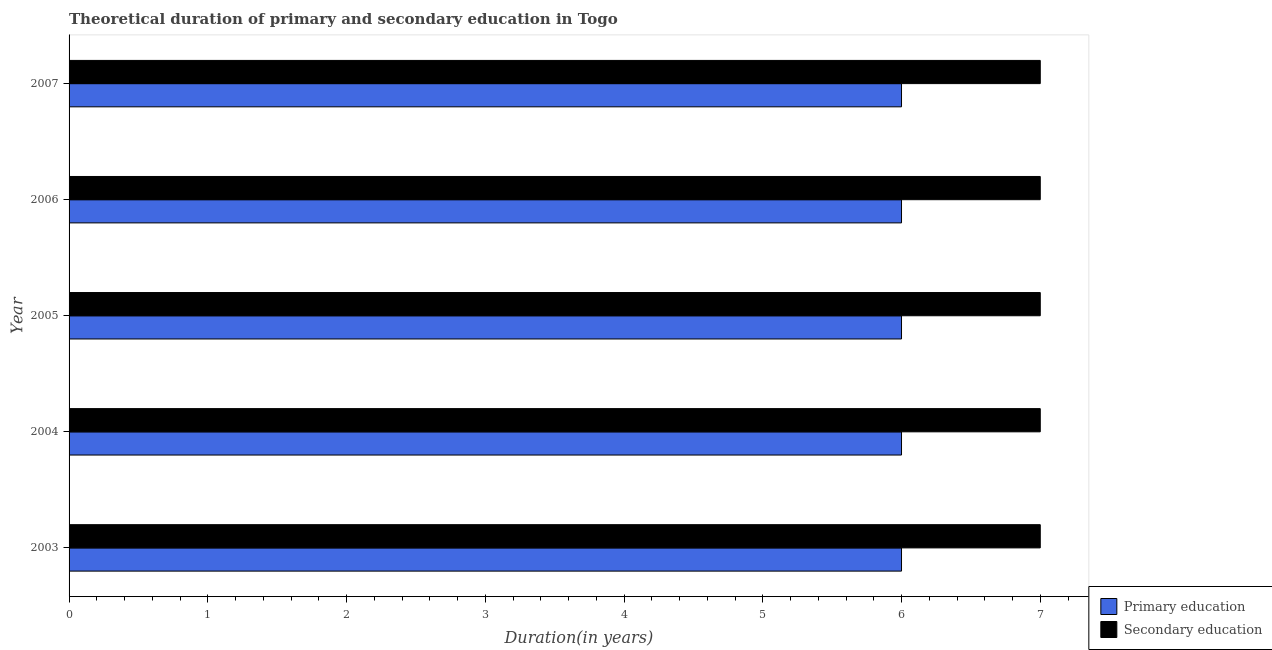Are the number of bars on each tick of the Y-axis equal?
Provide a succinct answer. Yes. What is the label of the 2nd group of bars from the top?
Your response must be concise. 2006. In how many cases, is the number of bars for a given year not equal to the number of legend labels?
Keep it short and to the point. 0. Across all years, what is the maximum duration of secondary education?
Make the answer very short. 7. Across all years, what is the minimum duration of secondary education?
Your response must be concise. 7. In which year was the duration of primary education maximum?
Your answer should be very brief. 2003. In which year was the duration of primary education minimum?
Your response must be concise. 2003. What is the total duration of secondary education in the graph?
Ensure brevity in your answer.  35. What is the difference between the duration of primary education in 2003 and that in 2005?
Your answer should be very brief. 0. What is the difference between the duration of primary education in 2003 and the duration of secondary education in 2004?
Give a very brief answer. -1. What is the average duration of secondary education per year?
Your answer should be compact. 7. In the year 2007, what is the difference between the duration of secondary education and duration of primary education?
Make the answer very short. 1. What is the ratio of the duration of primary education in 2003 to that in 2005?
Offer a terse response. 1. What does the 1st bar from the top in 2004 represents?
Keep it short and to the point. Secondary education. What does the 2nd bar from the bottom in 2004 represents?
Provide a succinct answer. Secondary education. How many years are there in the graph?
Provide a short and direct response. 5. Does the graph contain any zero values?
Offer a very short reply. No. Does the graph contain grids?
Offer a very short reply. No. How are the legend labels stacked?
Offer a very short reply. Vertical. What is the title of the graph?
Give a very brief answer. Theoretical duration of primary and secondary education in Togo. What is the label or title of the X-axis?
Make the answer very short. Duration(in years). What is the Duration(in years) in Primary education in 2003?
Provide a short and direct response. 6. What is the Duration(in years) in Primary education in 2004?
Ensure brevity in your answer.  6. What is the Duration(in years) of Secondary education in 2004?
Ensure brevity in your answer.  7. What is the Duration(in years) of Secondary education in 2005?
Give a very brief answer. 7. What is the Duration(in years) of Primary education in 2007?
Make the answer very short. 6. Across all years, what is the minimum Duration(in years) in Primary education?
Provide a succinct answer. 6. What is the total Duration(in years) of Secondary education in the graph?
Your response must be concise. 35. What is the difference between the Duration(in years) in Secondary education in 2003 and that in 2004?
Your response must be concise. 0. What is the difference between the Duration(in years) of Secondary education in 2003 and that in 2007?
Provide a short and direct response. 0. What is the difference between the Duration(in years) of Secondary education in 2004 and that in 2005?
Ensure brevity in your answer.  0. What is the difference between the Duration(in years) of Primary education in 2004 and that in 2006?
Offer a very short reply. 0. What is the difference between the Duration(in years) in Secondary education in 2004 and that in 2007?
Your response must be concise. 0. What is the difference between the Duration(in years) in Primary education in 2005 and that in 2006?
Your answer should be compact. 0. What is the difference between the Duration(in years) in Secondary education in 2006 and that in 2007?
Your answer should be compact. 0. What is the difference between the Duration(in years) of Primary education in 2003 and the Duration(in years) of Secondary education in 2007?
Provide a short and direct response. -1. What is the difference between the Duration(in years) in Primary education in 2004 and the Duration(in years) in Secondary education in 2007?
Ensure brevity in your answer.  -1. What is the difference between the Duration(in years) in Primary education in 2005 and the Duration(in years) in Secondary education in 2006?
Your answer should be compact. -1. What is the difference between the Duration(in years) in Primary education in 2005 and the Duration(in years) in Secondary education in 2007?
Your answer should be compact. -1. In the year 2003, what is the difference between the Duration(in years) in Primary education and Duration(in years) in Secondary education?
Give a very brief answer. -1. What is the ratio of the Duration(in years) of Secondary education in 2003 to that in 2004?
Provide a succinct answer. 1. What is the ratio of the Duration(in years) of Primary education in 2003 to that in 2005?
Offer a very short reply. 1. What is the ratio of the Duration(in years) in Secondary education in 2003 to that in 2005?
Keep it short and to the point. 1. What is the ratio of the Duration(in years) of Secondary education in 2003 to that in 2006?
Make the answer very short. 1. What is the ratio of the Duration(in years) of Primary education in 2003 to that in 2007?
Provide a succinct answer. 1. What is the ratio of the Duration(in years) in Primary education in 2004 to that in 2006?
Your answer should be compact. 1. What is the ratio of the Duration(in years) of Secondary education in 2004 to that in 2006?
Keep it short and to the point. 1. What is the ratio of the Duration(in years) of Primary education in 2005 to that in 2006?
Keep it short and to the point. 1. What is the ratio of the Duration(in years) in Secondary education in 2005 to that in 2006?
Make the answer very short. 1. What is the ratio of the Duration(in years) in Primary education in 2005 to that in 2007?
Provide a succinct answer. 1. What is the ratio of the Duration(in years) in Primary education in 2006 to that in 2007?
Offer a very short reply. 1. What is the difference between the highest and the lowest Duration(in years) in Primary education?
Make the answer very short. 0. What is the difference between the highest and the lowest Duration(in years) in Secondary education?
Provide a short and direct response. 0. 